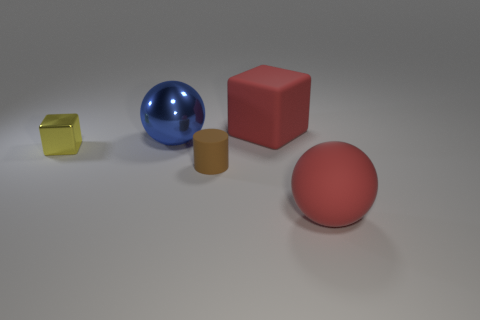There is a object on the right side of the big red matte object that is left of the sphere in front of the small yellow metal cube; what is its color?
Your answer should be compact. Red. Do the small cube and the small brown cylinder have the same material?
Offer a terse response. No. There is a cube in front of the large sphere to the left of the big red cube; is there a large matte cube that is to the right of it?
Ensure brevity in your answer.  Yes. Is the big rubber ball the same color as the large cube?
Provide a short and direct response. Yes. Are there fewer big red cylinders than large red matte things?
Ensure brevity in your answer.  Yes. Is the material of the cube that is behind the blue thing the same as the big sphere to the right of the brown rubber cylinder?
Provide a short and direct response. Yes. Is the number of shiny spheres that are in front of the tiny cube less than the number of tiny brown rubber cylinders?
Offer a terse response. Yes. There is a large sphere right of the red matte block; what number of red matte objects are in front of it?
Provide a succinct answer. 0. There is a thing that is behind the tiny brown object and right of the large blue sphere; how big is it?
Ensure brevity in your answer.  Large. Does the tiny yellow cube have the same material as the ball behind the tiny yellow thing?
Ensure brevity in your answer.  Yes. 